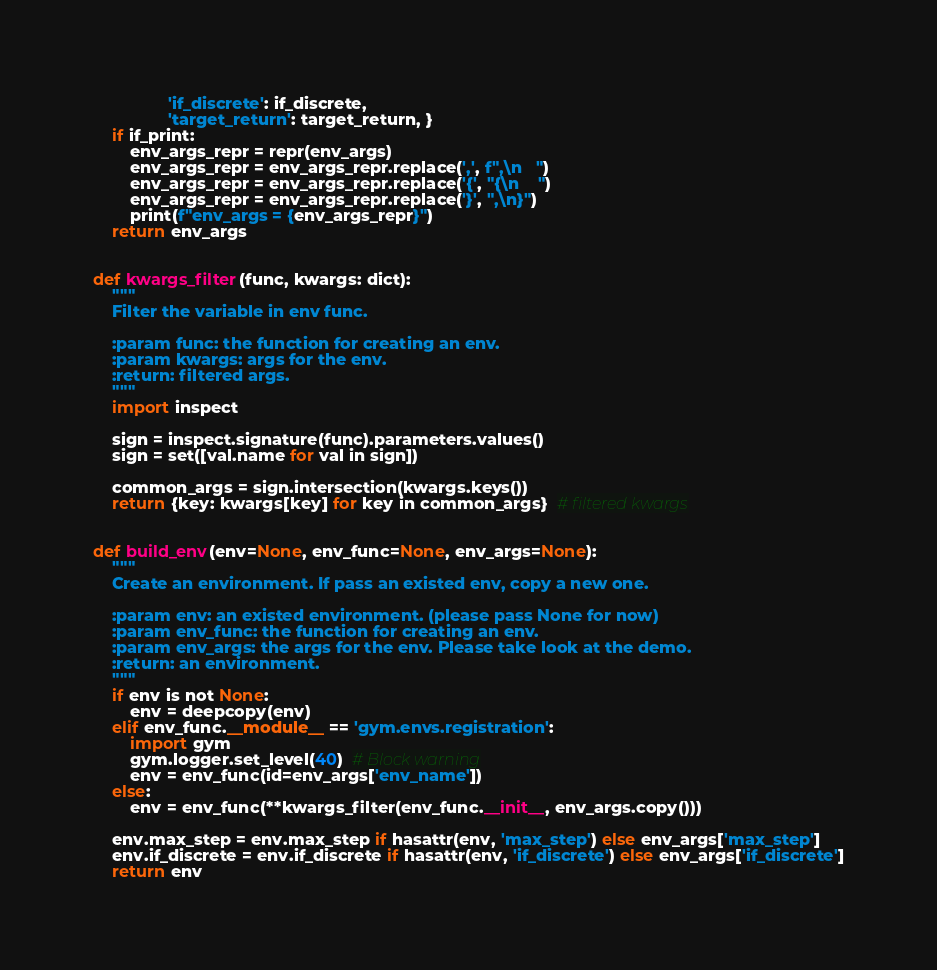<code> <loc_0><loc_0><loc_500><loc_500><_Python_>                'if_discrete': if_discrete,
                'target_return': target_return, }
    if if_print:
        env_args_repr = repr(env_args)
        env_args_repr = env_args_repr.replace(',', f",\n   ")
        env_args_repr = env_args_repr.replace('{', "{\n    ")
        env_args_repr = env_args_repr.replace('}', ",\n}")
        print(f"env_args = {env_args_repr}")
    return env_args


def kwargs_filter(func, kwargs: dict):
    """
    Filter the variable in env func.

    :param func: the function for creating an env.
    :param kwargs: args for the env.
    :return: filtered args.
    """
    import inspect

    sign = inspect.signature(func).parameters.values()
    sign = set([val.name for val in sign])

    common_args = sign.intersection(kwargs.keys())
    return {key: kwargs[key] for key in common_args}  # filtered kwargs


def build_env(env=None, env_func=None, env_args=None):
    """
    Create an environment. If pass an existed env, copy a new one.

    :param env: an existed environment. (please pass None for now)
    :param env_func: the function for creating an env.
    :param env_args: the args for the env. Please take look at the demo.
    :return: an environment.
    """
    if env is not None:
        env = deepcopy(env)
    elif env_func.__module__ == 'gym.envs.registration':
        import gym
        gym.logger.set_level(40)  # Block warning
        env = env_func(id=env_args['env_name'])
    else:
        env = env_func(**kwargs_filter(env_func.__init__, env_args.copy()))

    env.max_step = env.max_step if hasattr(env, 'max_step') else env_args['max_step']
    env.if_discrete = env.if_discrete if hasattr(env, 'if_discrete') else env_args['if_discrete']
    return env
</code> 